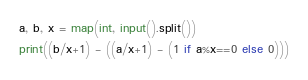<code> <loc_0><loc_0><loc_500><loc_500><_Python_>a, b, x = map(int, input().split())
print((b/x+1) - ((a/x+1) - (1 if a%x==0 else 0)))
</code> 